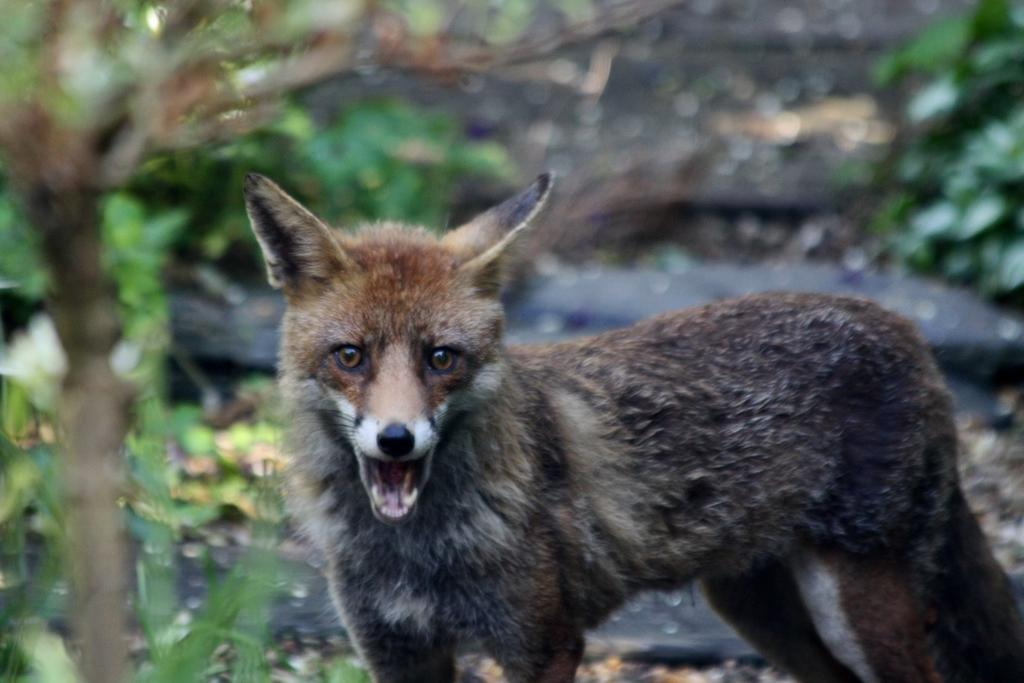What type of living creature is present in the image? There is an animal in the image. What can be seen in the background of the image? There are trees in the background of the image. What type of potato is being sliced with a knife in the image? There is no potato or knife present in the image; it features an animal and trees in the background. 